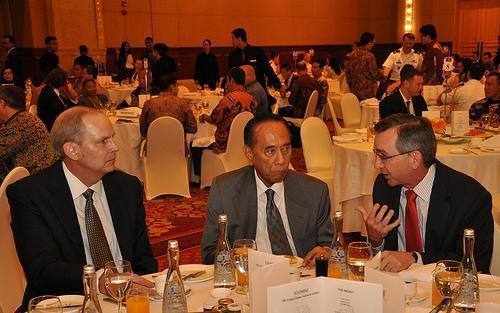How many men at the first table are wearing glasses?
Give a very brief answer. 1. 